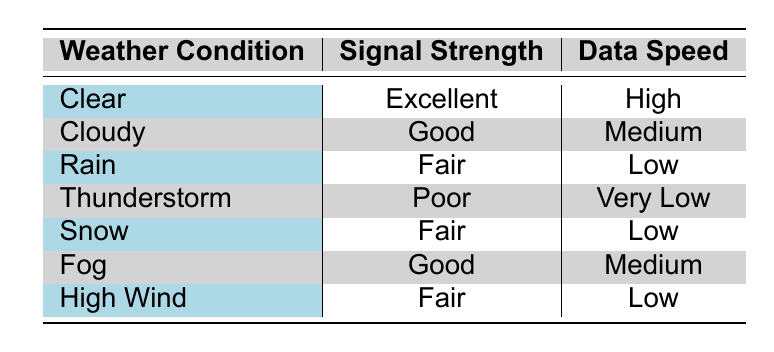What is the signal strength during clear weather conditions? The table indicates that during clear weather conditions, the signal strength is listed as "Excellent."
Answer: Excellent Which weather condition has the lowest data speed? From the table, the "Thunderstorm" condition is associated with the data speed labeled as "Very Low," which is lower than all other conditions.
Answer: Thunderstorm How many weather conditions report 'Fair' signal strength? We can see from the table that "Rain," "Snow," and "High Wind" all have 'Fair' signal strength. Counting these gives us a total of 3 conditions.
Answer: 3 Is the data speed during snowy conditions categorized as high? The table shows that the data speed during snowy conditions is "Low," which does not meet the criteria for being classified as high.
Answer: No What is the average data speed rating for all weather conditions? The data speeds are categorized as High, Medium, Low, and Very Low. We can assign numerical values: High=3, Medium=2, Low=1, Very Low=0 and calculate the average: (3 + 2 + 1 + 0 + 1 + 2 + 1)/7 = 1.14, which estimates to 'Low' overall.
Answer: Low Which weather conditions have good or excellent signal strength? Referring to the table, "Clear" (Excellent), "Cloudy" (Good), and "Fog" (Good) show either good or excellent signal strength. Here, we have 3 conditions meeting this criterion.
Answer: 3 Does any weather condition show a combination of poor signal strength and low data speed? The table reveals that "Thunderstorm" has "Poor" signal strength and "Very Low" data speed, confirming that such a combination exists for this condition.
Answer: Yes What is the difference in data speed ratings between clear and thunderstorm conditions? The data speed rating for "Clear" is "High," while for "Thunderstorm," it is "Very Low." In numerical terms: High=3 and Very Low=0, thus the difference is 3 - 0 = 3, indicating a significant disparity.
Answer: 3 